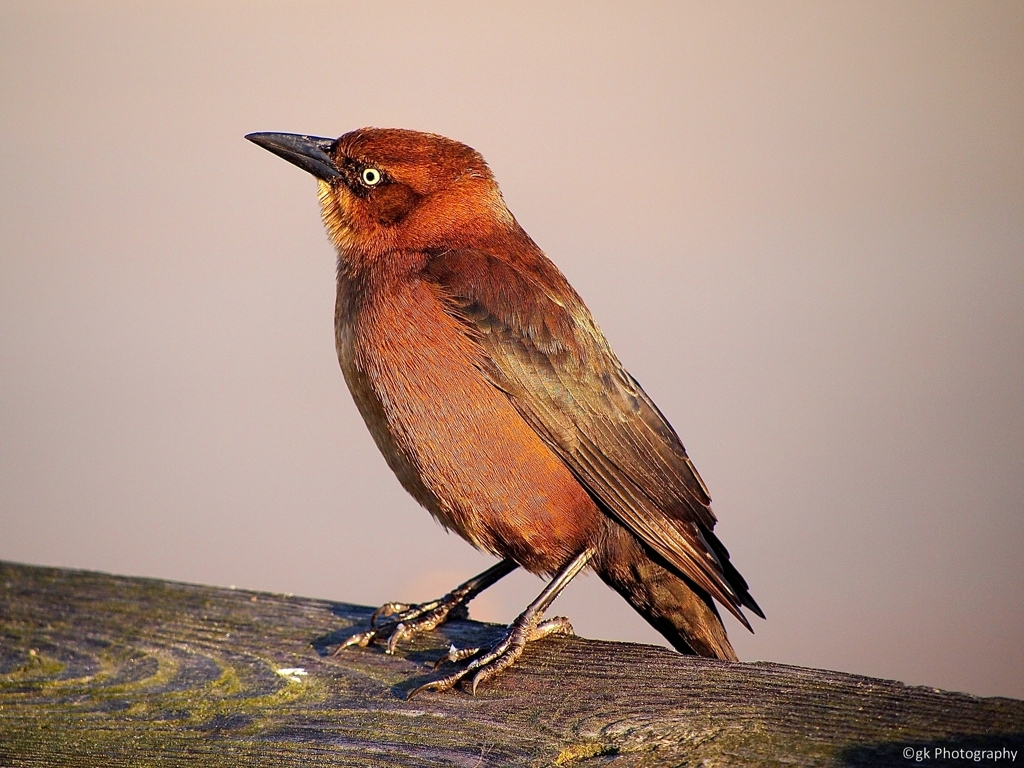Is the texture of the layers clear?
A. No
B. Yes
Answer with the option's letter from the given choices directly.
 B. 